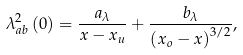Convert formula to latex. <formula><loc_0><loc_0><loc_500><loc_500>\lambda _ { a b } ^ { 2 } \left ( 0 \right ) = \frac { a _ { \lambda } } { x - x _ { u } } + \frac { b _ { \lambda } } { \left ( x _ { o } - x \right ) ^ { 3 / 2 } } ,</formula> 